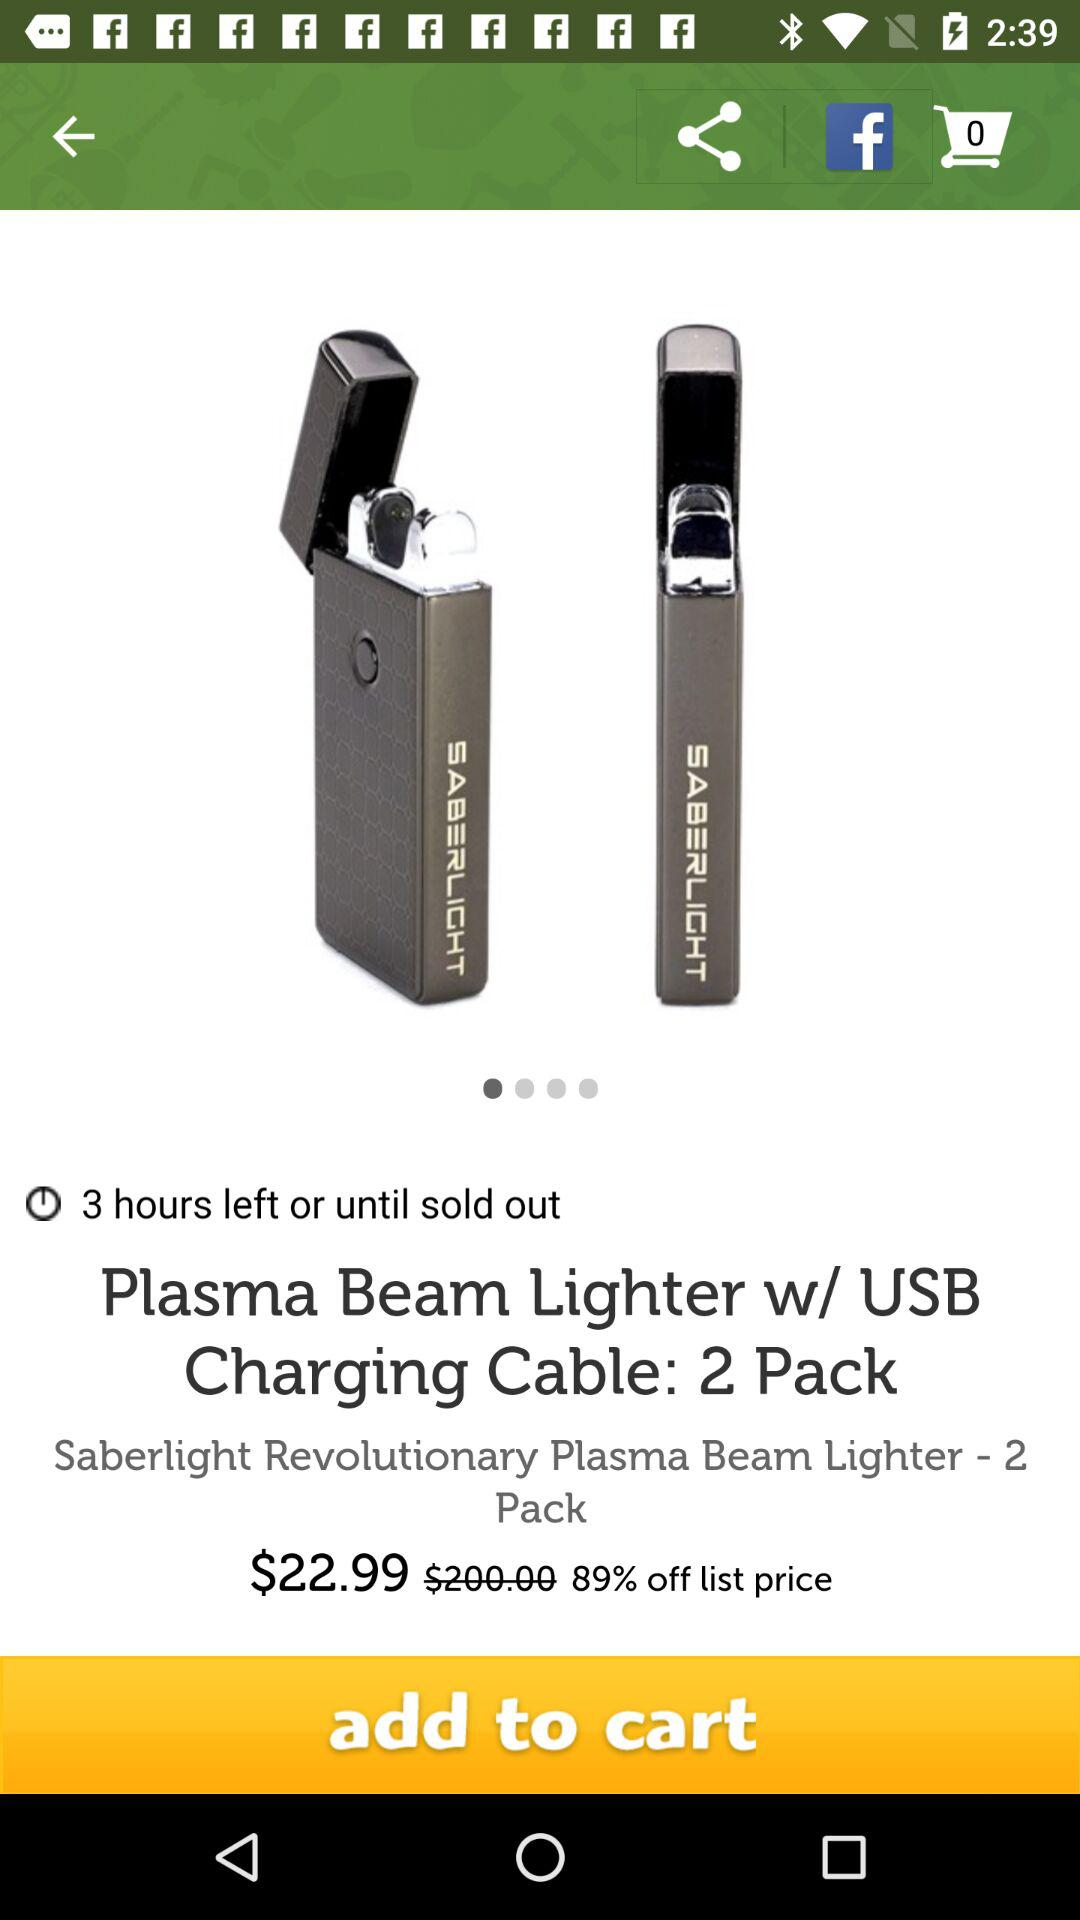How long will the discount last? The discount will last for 3 hours. 